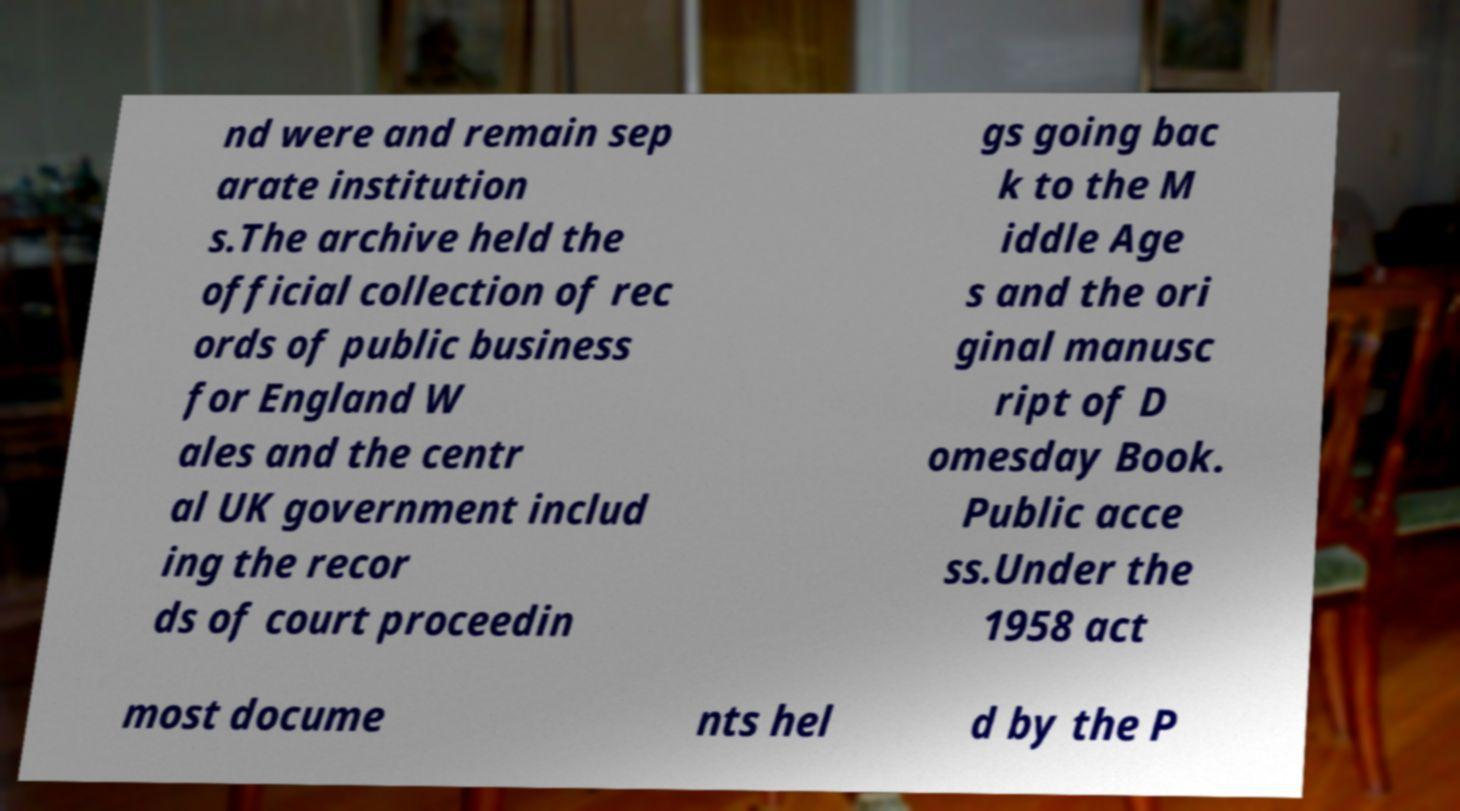Can you accurately transcribe the text from the provided image for me? nd were and remain sep arate institution s.The archive held the official collection of rec ords of public business for England W ales and the centr al UK government includ ing the recor ds of court proceedin gs going bac k to the M iddle Age s and the ori ginal manusc ript of D omesday Book. Public acce ss.Under the 1958 act most docume nts hel d by the P 